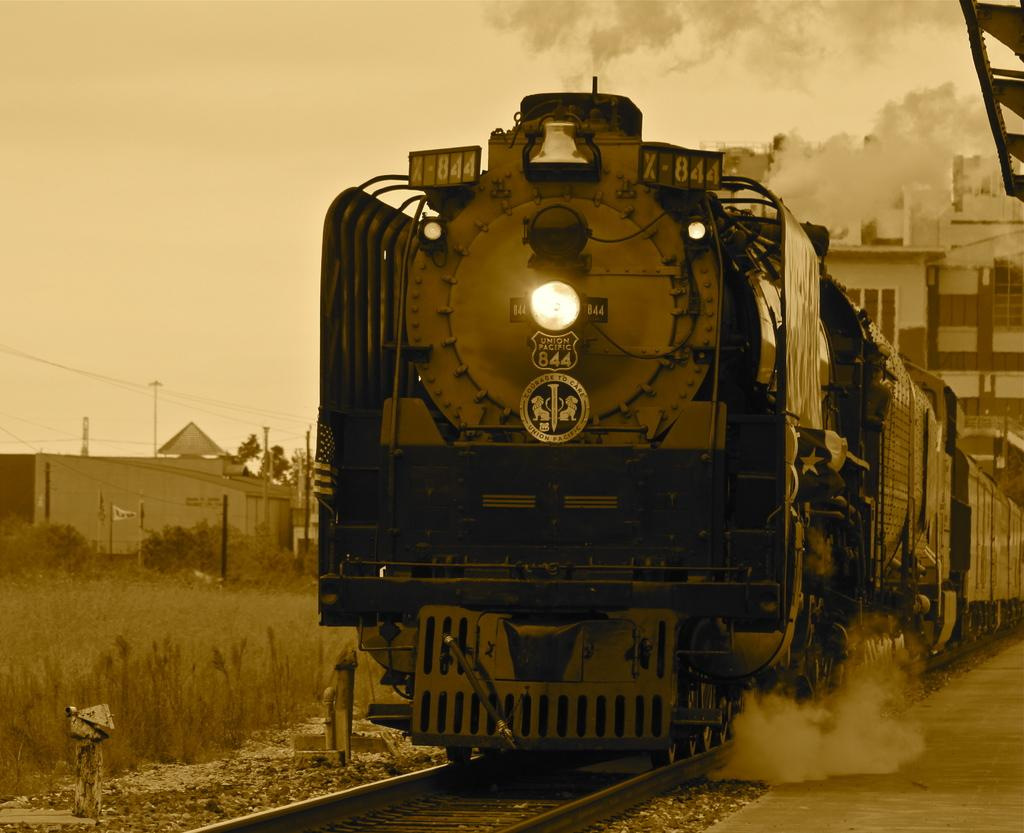What is the main subject of the image? The main subject of the image is a train. What is the train doing in the image? The train is moving on a track. What can be seen in the background of the image? There are planets and houses visible in the background of the image. What is the condition of the sky in the image? The sky is clear at the top of the image. Where is the mother standing in the image? There is no mother present in the image; it features a train moving on a track with planets and houses in the background. How many boats can be seen in the image? There are no boats present in the image. 